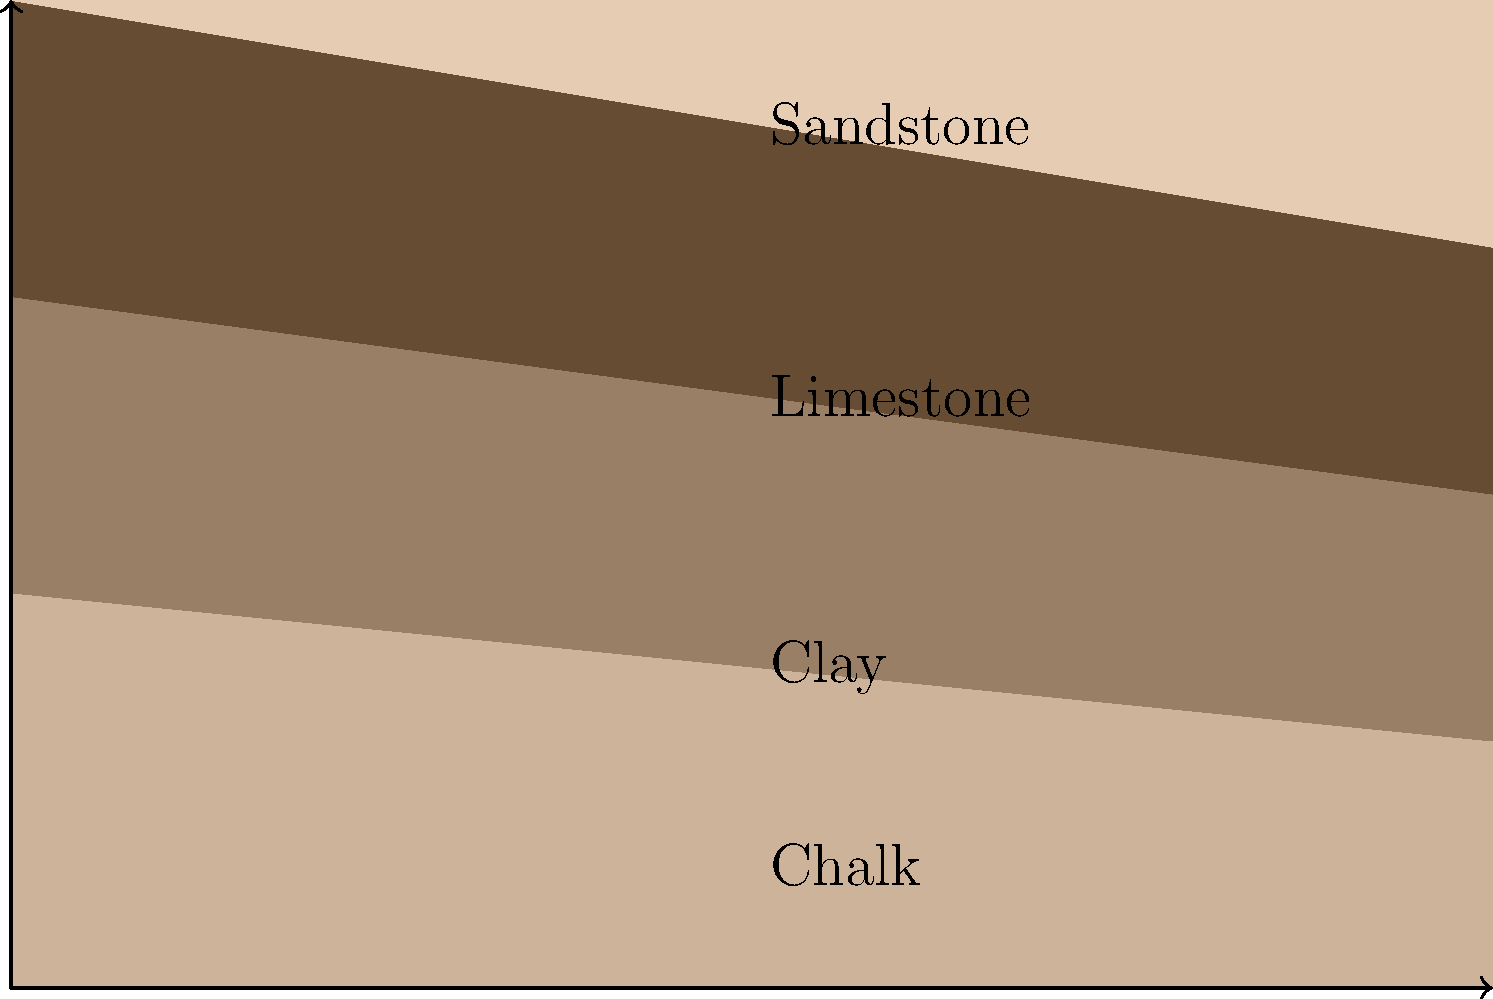Based on the cross-sectional diagram of rock layers in the Camberley area, what geological process is most likely responsible for the formation of these strata, and how does this relate to the local landscape? To answer this question, we need to analyze the rock layers shown in the diagram and consider the geological processes that could have formed them:

1. Layer identification:
   - The bottom layer is Chalk
   - Above it is Clay
   - Then Limestone
   - The top layer is Sandstone

2. Layer formation:
   - These sedimentary rocks were deposited in a marine environment over millions of years.
   - The order of deposition indicates a changing environment from deep sea (Chalk) to shallower waters (Clay and Limestone) to coastal or terrestrial environments (Sandstone).

3. Layer inclination:
   - The layers are not horizontal but inclined, with the left side higher than the right.
   - This suggests tectonic activity after deposition, causing uplift and tilting of the strata.

4. Geological process:
   - The primary process responsible for this formation is marine regression, where sea levels gradually receded over time.
   - This regression was likely coupled with regional uplift, explaining the tilted layers.

5. Relation to local landscape:
   - The inclined layers would result in a landscape with gentle slopes and potential escarpments where harder rocks (Limestone, Sandstone) outcrop.
   - The varying rock types would influence soil composition, drainage, and vegetation in different areas of Camberley.
   - The exposure of different rock layers due to erosion could create a varied topography with hills and valleys.

In conclusion, the most likely geological process responsible for this formation is marine regression combined with tectonic uplift. This process has created a landscape characterized by gentle slopes, varied soil types, and potentially distinct vegetation zones corresponding to the underlying rock layers.
Answer: Marine regression with tectonic uplift, creating a landscape of gentle slopes and varied soil types. 